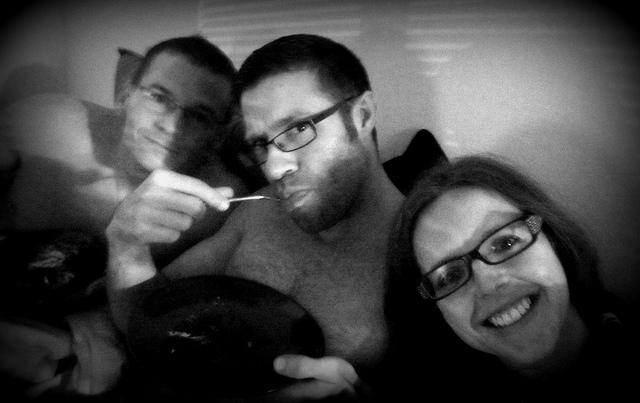What is a good word to describe all of these people?

Choices:
A) toddlers
B) women
C) bespectacled
D) senior citizens bespectacled 